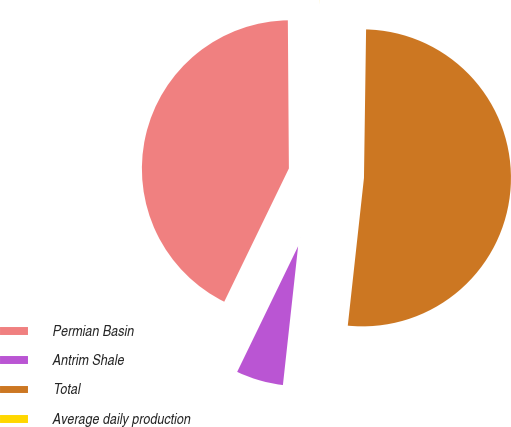Convert chart. <chart><loc_0><loc_0><loc_500><loc_500><pie_chart><fcel>Permian Basin<fcel>Antrim Shale<fcel>Total<fcel>Average daily production<nl><fcel>42.7%<fcel>5.45%<fcel>51.51%<fcel>0.34%<nl></chart> 